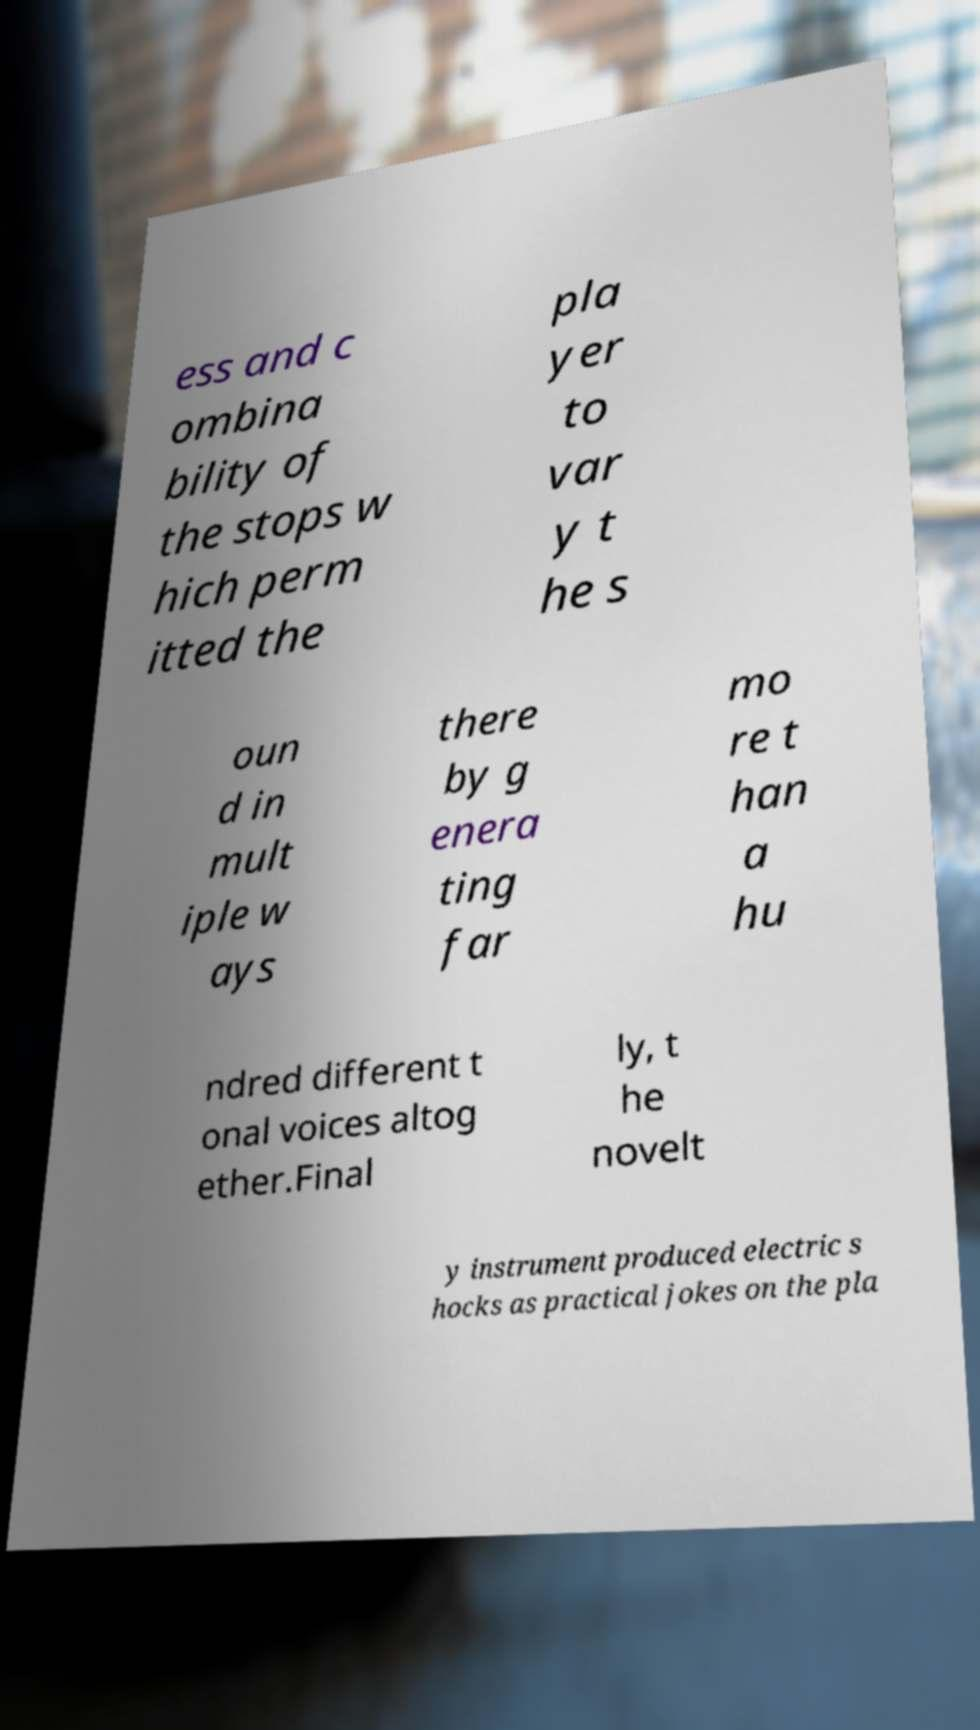Please read and relay the text visible in this image. What does it say? ess and c ombina bility of the stops w hich perm itted the pla yer to var y t he s oun d in mult iple w ays there by g enera ting far mo re t han a hu ndred different t onal voices altog ether.Final ly, t he novelt y instrument produced electric s hocks as practical jokes on the pla 